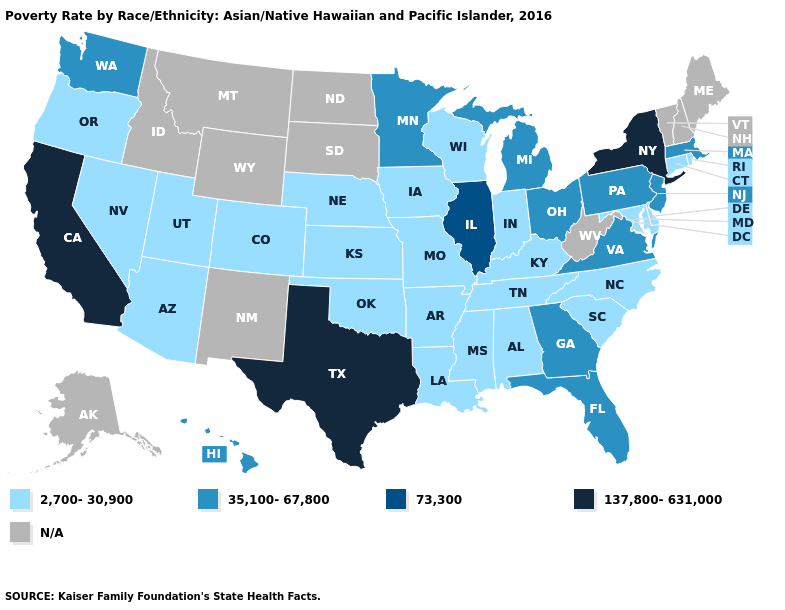Name the states that have a value in the range 137,800-631,000?
Short answer required. California, New York, Texas. What is the highest value in the West ?
Be succinct. 137,800-631,000. What is the lowest value in the USA?
Short answer required. 2,700-30,900. Does Minnesota have the lowest value in the USA?
Answer briefly. No. What is the value of Alaska?
Short answer required. N/A. Which states have the lowest value in the MidWest?
Short answer required. Indiana, Iowa, Kansas, Missouri, Nebraska, Wisconsin. How many symbols are there in the legend?
Answer briefly. 5. Name the states that have a value in the range 73,300?
Be succinct. Illinois. How many symbols are there in the legend?
Write a very short answer. 5. Name the states that have a value in the range 35,100-67,800?
Write a very short answer. Florida, Georgia, Hawaii, Massachusetts, Michigan, Minnesota, New Jersey, Ohio, Pennsylvania, Virginia, Washington. Does the first symbol in the legend represent the smallest category?
Quick response, please. Yes. What is the value of New York?
Be succinct. 137,800-631,000. Name the states that have a value in the range 35,100-67,800?
Concise answer only. Florida, Georgia, Hawaii, Massachusetts, Michigan, Minnesota, New Jersey, Ohio, Pennsylvania, Virginia, Washington. What is the highest value in the USA?
Be succinct. 137,800-631,000. What is the value of Idaho?
Answer briefly. N/A. 